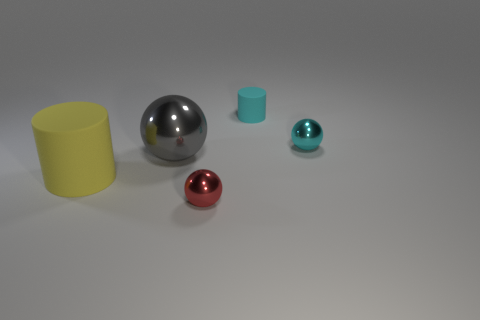Subtract all big balls. How many balls are left? 2 Add 1 matte cubes. How many objects exist? 6 Subtract 1 cylinders. How many cylinders are left? 1 Subtract all balls. How many objects are left? 2 Add 2 red shiny spheres. How many red shiny spheres are left? 3 Add 4 large yellow rubber cylinders. How many large yellow rubber cylinders exist? 5 Subtract 1 yellow cylinders. How many objects are left? 4 Subtract all brown spheres. Subtract all blue cubes. How many spheres are left? 3 Subtract all yellow matte cylinders. Subtract all tiny yellow matte objects. How many objects are left? 4 